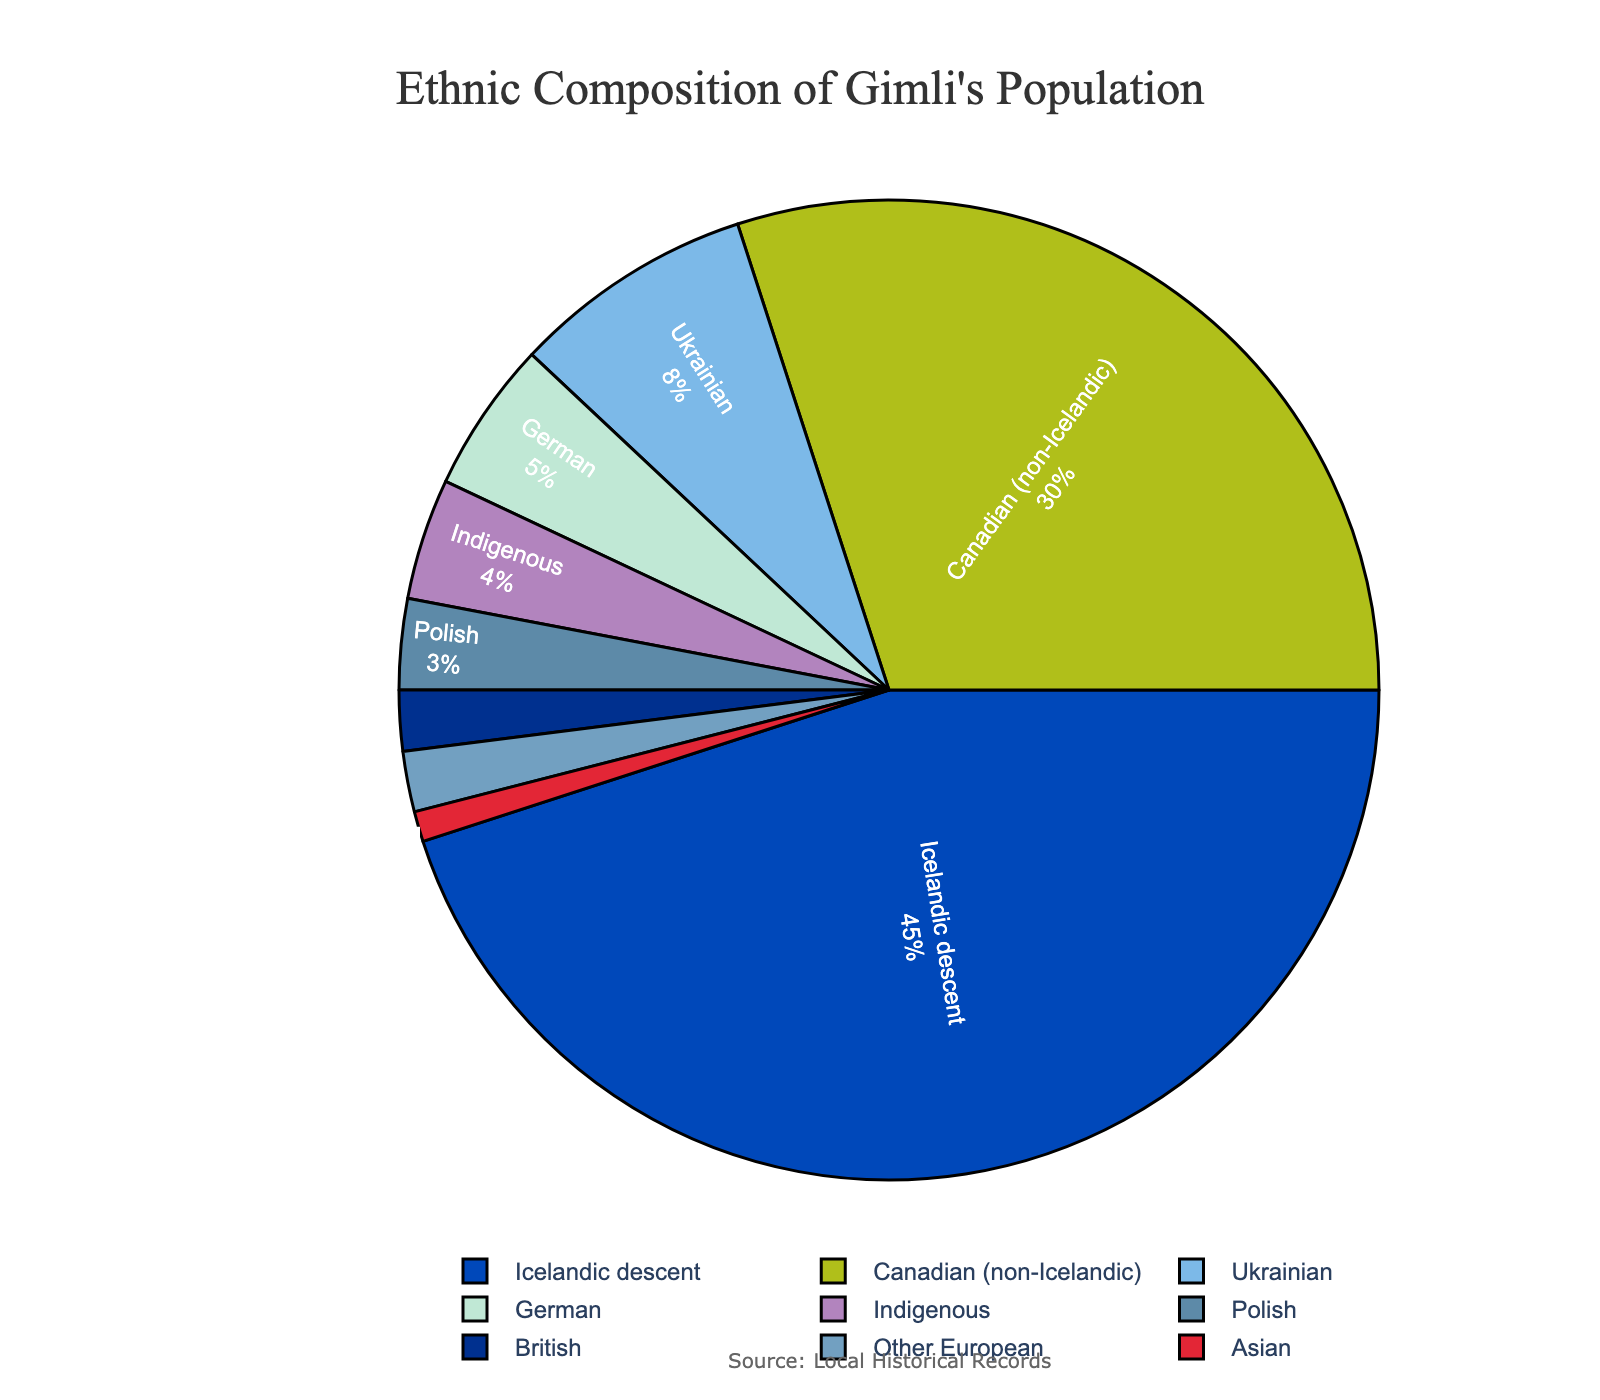What is the percentage of Gimli's population that is not of Icelandic descent? The chart shows that 45% of Gimli's population is of Icelandic descent. To find the percentage that is not of Icelandic descent, subtract this percentage from 100%. Therefore, 100% - 45% = 55%
Answer: 55% Which two ethnic groups combined make up the smallest percentage of Gimli's population? The chart shows the percentages of all ethnic groups. The two groups with the smallest percentages are Asian (1%) and British (2%). Combined, they make up 1% + 2% = 3%
Answer: Asian and British Is the percentage of people of Icelandic descent more than double the percentage of Canadian (non-Icelandic) descent? The percentage of Icelandic descent is 45%, and Canadian (non-Icelandic) descent is 30%. Double the Canadian (non-Icelandic) percentage is 30% x 2 = 60%. Since 45% is less than 60%, the percentage of Icelandic descent is not more than double.
Answer: No What is the difference in percentage between the groups of German and Indigenous descent? The chart shows that the percentage of German descent is 5% and Indigenous descent is 4%. The difference is 5% - 4% = 1%
Answer: 1% What is the combined percentage of the three largest ethnic groups besides Icelandic descent? The three largest ethnic groups besides Icelandic descent are Canadian (30%), Ukrainian (8%), and German (5%). The combined percentage is 30% + 8% + 5% = 43%
Answer: 43% Which ethnic group has the smallest representation in Gimli's population, and what is its percentage? The chart shows various percentages, and the smallest percentage is for Asian descent, which is 1%
Answer: Asian, 1% How does the percentage of British descent compare with the combined percentage of Polish and Other European descent? The percentage of British descent is 2%, while Polish and Other European have percentages of 3% and 2%, respectively. Combined, Polish and Other European is 3% + 2% = 5%, which is greater than 2%
Answer: Less than What color represents the Icelandic descent on the pie chart? Since color assignment is not provided, you can identify the slice of Icelandic descent by its size (45%) and color in the legend.
Answer: Identify by size What percentage of the population falls into the Other European category? The chart shows the percentage for Other European is 2%
Answer: 2% Which ethnic group is twice the representation of the Indigenous group? The Indigenous group is 4%. The group that is twice its representation is German, at 5% which is not an exact fit, so there isn't a direct match. The British group is exactly 2% more, so technically no group exactly fits twice.
Answer: None specific 